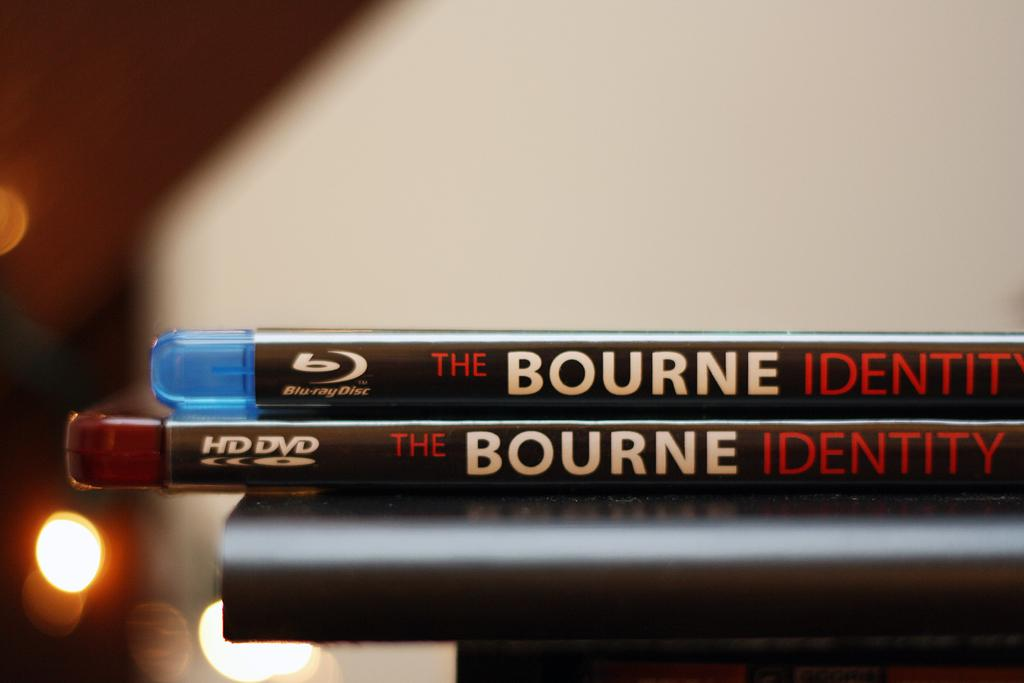<image>
Render a clear and concise summary of the photo. Two copies of the Bourne Identity are stacked on top of each other. 